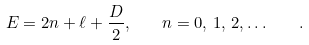<formula> <loc_0><loc_0><loc_500><loc_500>E = 2 n + \ell + \frac { D } { 2 } , \quad n = 0 , \, 1 , \, 2 , \dots \quad .</formula> 